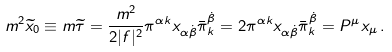<formula> <loc_0><loc_0><loc_500><loc_500>m ^ { 2 } \widetilde { x } _ { 0 } \equiv m \widetilde { \tau } = { \frac { m ^ { 2 } } { 2 | f | ^ { 2 } } } \pi ^ { \alpha k } x _ { \alpha \dot { \beta } } \bar { \pi } ^ { \dot { \beta } } _ { k } = 2 \pi ^ { \alpha k } x _ { \alpha \dot { \beta } } \bar { \pi } ^ { \dot { \beta } } _ { k } = P ^ { \mu } x _ { \mu } \, .</formula> 